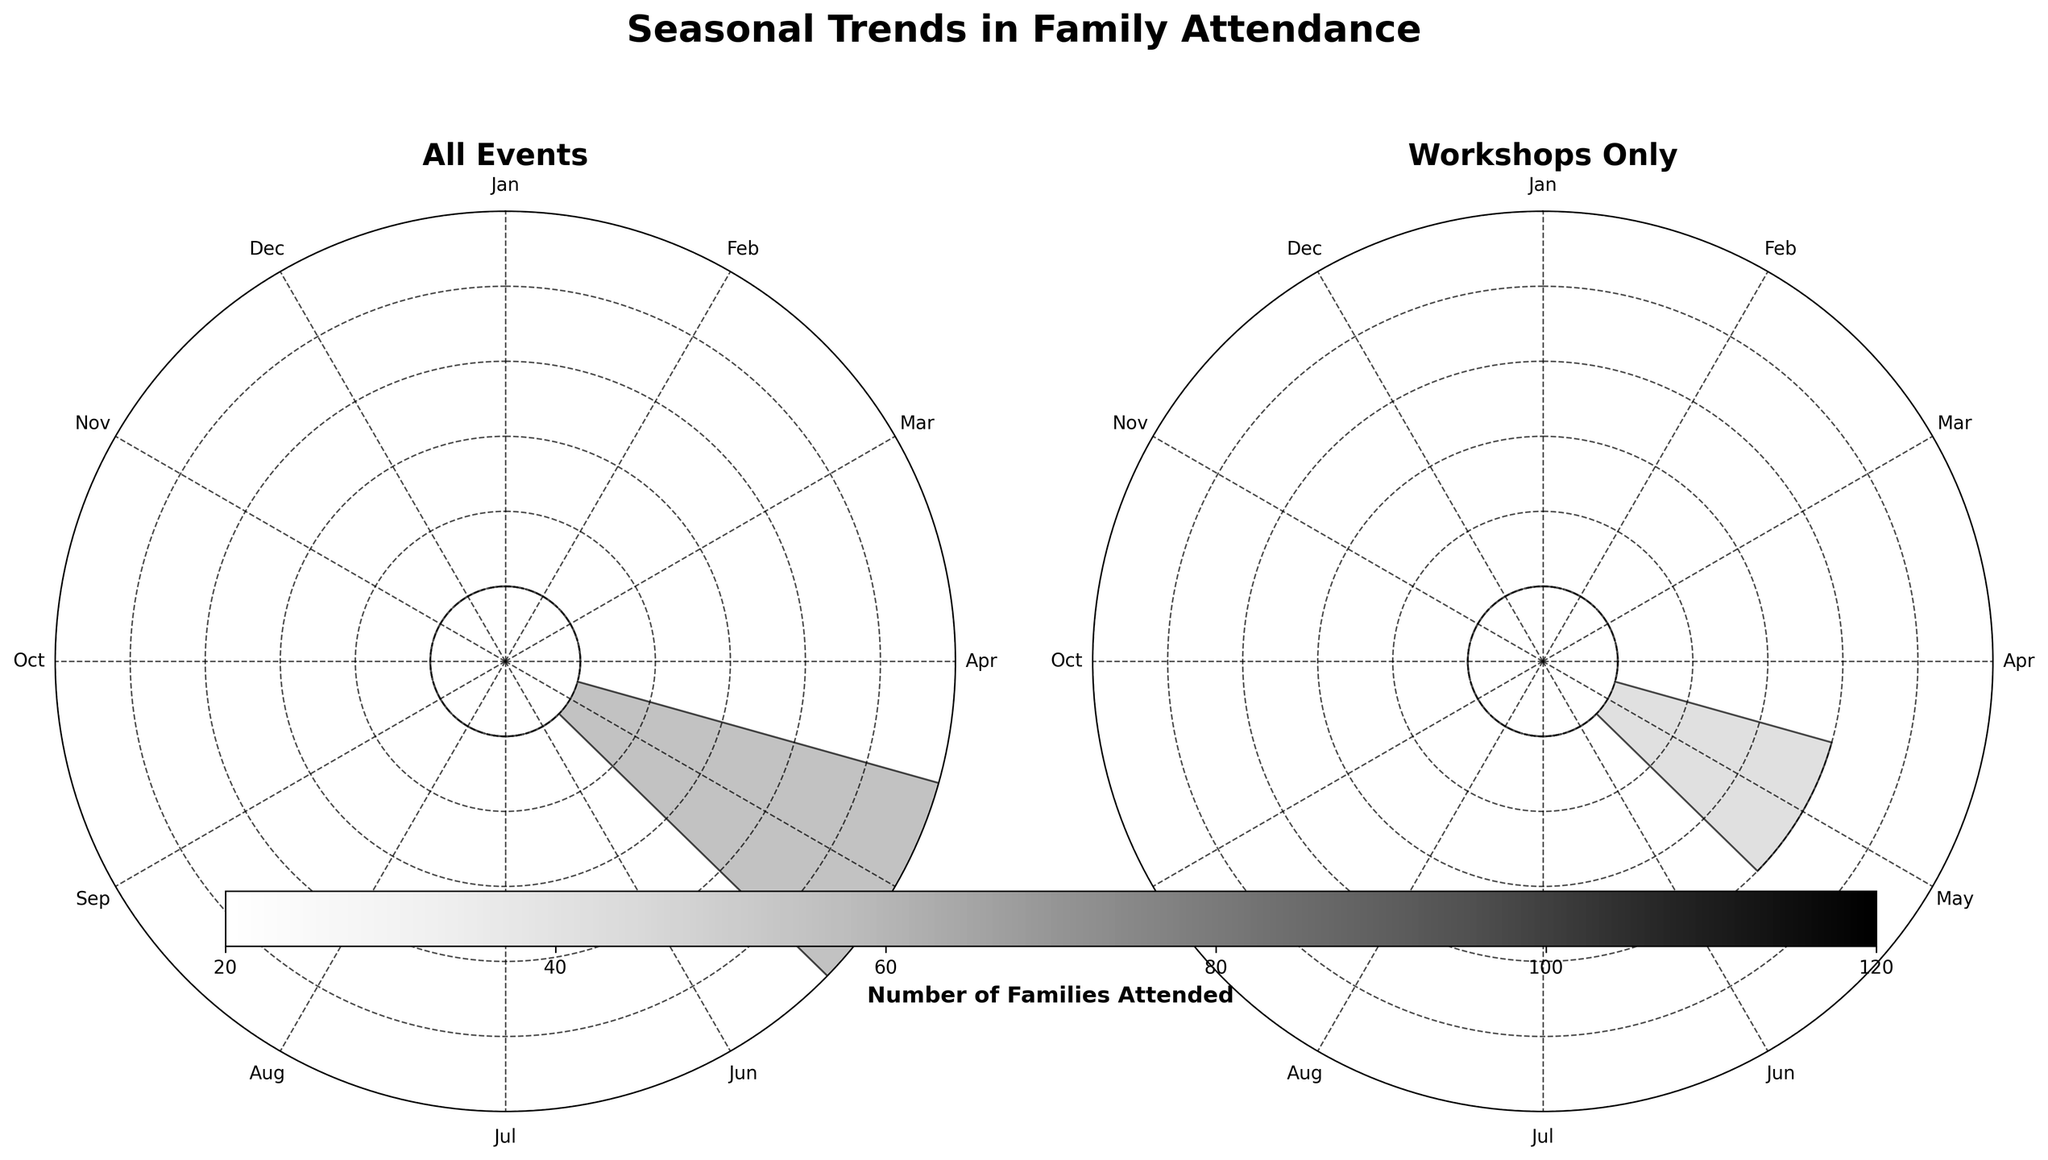How many families attended events in June? Look at the subplot titled "All Events" and locate the bar corresponding to June. The height reveals the number of families.
Answer: 85 What is the difference in attendance between "Workshops Only" and "All Events" in January? Compare the heights of the bars for January in both subplots. The "All Events" subplot shows 83 families, while the "Workshops Only" subplot shows 83 families as well. The difference is 83 - 83.
Answer: 0 Which month had the highest attendance for "All Events"? Look at the subplot titled "All Events" and find the month with the tallest bar. July has the highest attendance with 90 families.
Answer: July Does September hold a higher workshop attendance compared to October? Compare the heights of the bars for September and October in the "Workshops Only" subplot. September has slightly lower attendance than October (50 vs. 58 families).
Answer: No How many families attended workshops in April? Find the bar corresponding to April in the "Workshops Only" subplot. The height indicates the number of families.
Answer: 48 Compare the attendance in May and June for "All Events". Which month saw more families? Look at the heights of the bars for May and June in the "All Events" subplot. June had 85 families, whereas May had 75 families. June saw more families.
Answer: June What is the sum of families that attended "Workshops" in February and March? Add the heights of the bars for February and March in the "Workshops Only" subplot. February had 42 families, and March had 50. The sum is 42 + 50 = 92.
Answer: 92 Were there more families attending events in August compared to January? In the "All Events" subplot, compare the heights of the bars for August and January. August had 80 families, whereas January had 83 families.
Answer: No Which month had the lowest attendance for "All Events"? Look at the heights of all bars in the "All Events" subplot. November has the lowest attendance with 40 families.
Answer: November 